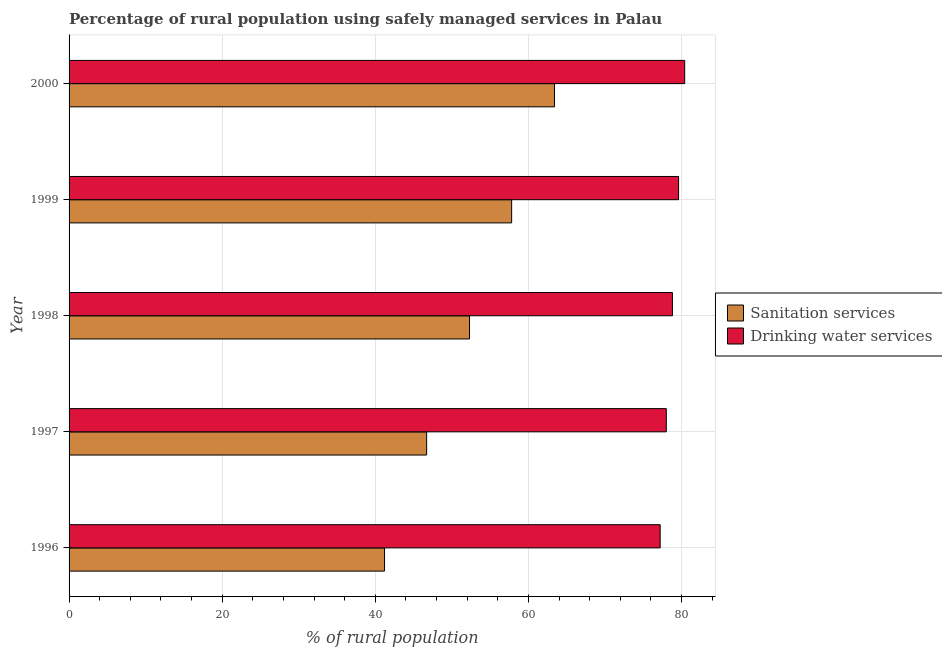How many different coloured bars are there?
Provide a succinct answer. 2. How many groups of bars are there?
Offer a very short reply. 5. Are the number of bars per tick equal to the number of legend labels?
Offer a terse response. Yes. Are the number of bars on each tick of the Y-axis equal?
Your response must be concise. Yes. How many bars are there on the 5th tick from the top?
Ensure brevity in your answer.  2. What is the label of the 4th group of bars from the top?
Give a very brief answer. 1997. In how many cases, is the number of bars for a given year not equal to the number of legend labels?
Give a very brief answer. 0. What is the percentage of rural population who used sanitation services in 2000?
Provide a succinct answer. 63.4. Across all years, what is the maximum percentage of rural population who used drinking water services?
Make the answer very short. 80.4. Across all years, what is the minimum percentage of rural population who used sanitation services?
Your answer should be very brief. 41.2. In which year was the percentage of rural population who used drinking water services maximum?
Make the answer very short. 2000. In which year was the percentage of rural population who used sanitation services minimum?
Provide a short and direct response. 1996. What is the total percentage of rural population who used sanitation services in the graph?
Your response must be concise. 261.4. What is the difference between the percentage of rural population who used drinking water services in 1998 and the percentage of rural population who used sanitation services in 1996?
Your answer should be compact. 37.6. What is the average percentage of rural population who used drinking water services per year?
Provide a succinct answer. 78.8. In the year 1997, what is the difference between the percentage of rural population who used sanitation services and percentage of rural population who used drinking water services?
Your answer should be very brief. -31.3. In how many years, is the percentage of rural population who used drinking water services greater than 12 %?
Provide a short and direct response. 5. What is the ratio of the percentage of rural population who used drinking water services in 1999 to that in 2000?
Offer a very short reply. 0.99. Is the percentage of rural population who used sanitation services in 1998 less than that in 2000?
Your answer should be very brief. Yes. Is the difference between the percentage of rural population who used sanitation services in 1998 and 2000 greater than the difference between the percentage of rural population who used drinking water services in 1998 and 2000?
Your response must be concise. No. What is the difference between the highest and the second highest percentage of rural population who used drinking water services?
Keep it short and to the point. 0.8. Is the sum of the percentage of rural population who used drinking water services in 1998 and 2000 greater than the maximum percentage of rural population who used sanitation services across all years?
Offer a terse response. Yes. What does the 1st bar from the top in 1996 represents?
Offer a very short reply. Drinking water services. What does the 2nd bar from the bottom in 1996 represents?
Give a very brief answer. Drinking water services. How many bars are there?
Give a very brief answer. 10. How many years are there in the graph?
Provide a short and direct response. 5. Are the values on the major ticks of X-axis written in scientific E-notation?
Offer a very short reply. No. Does the graph contain any zero values?
Your response must be concise. No. Where does the legend appear in the graph?
Keep it short and to the point. Center right. How are the legend labels stacked?
Your answer should be very brief. Vertical. What is the title of the graph?
Give a very brief answer. Percentage of rural population using safely managed services in Palau. What is the label or title of the X-axis?
Provide a succinct answer. % of rural population. What is the % of rural population in Sanitation services in 1996?
Give a very brief answer. 41.2. What is the % of rural population of Drinking water services in 1996?
Make the answer very short. 77.2. What is the % of rural population in Sanitation services in 1997?
Your answer should be compact. 46.7. What is the % of rural population of Drinking water services in 1997?
Offer a very short reply. 78. What is the % of rural population of Sanitation services in 1998?
Make the answer very short. 52.3. What is the % of rural population of Drinking water services in 1998?
Provide a succinct answer. 78.8. What is the % of rural population of Sanitation services in 1999?
Ensure brevity in your answer.  57.8. What is the % of rural population of Drinking water services in 1999?
Provide a short and direct response. 79.6. What is the % of rural population of Sanitation services in 2000?
Ensure brevity in your answer.  63.4. What is the % of rural population in Drinking water services in 2000?
Your answer should be very brief. 80.4. Across all years, what is the maximum % of rural population in Sanitation services?
Provide a short and direct response. 63.4. Across all years, what is the maximum % of rural population of Drinking water services?
Your answer should be very brief. 80.4. Across all years, what is the minimum % of rural population of Sanitation services?
Provide a short and direct response. 41.2. Across all years, what is the minimum % of rural population of Drinking water services?
Provide a short and direct response. 77.2. What is the total % of rural population in Sanitation services in the graph?
Offer a very short reply. 261.4. What is the total % of rural population of Drinking water services in the graph?
Keep it short and to the point. 394. What is the difference between the % of rural population in Sanitation services in 1996 and that in 1997?
Offer a very short reply. -5.5. What is the difference between the % of rural population of Sanitation services in 1996 and that in 1998?
Your answer should be very brief. -11.1. What is the difference between the % of rural population of Sanitation services in 1996 and that in 1999?
Your answer should be very brief. -16.6. What is the difference between the % of rural population of Drinking water services in 1996 and that in 1999?
Ensure brevity in your answer.  -2.4. What is the difference between the % of rural population in Sanitation services in 1996 and that in 2000?
Your answer should be compact. -22.2. What is the difference between the % of rural population in Drinking water services in 1997 and that in 1999?
Provide a succinct answer. -1.6. What is the difference between the % of rural population in Sanitation services in 1997 and that in 2000?
Ensure brevity in your answer.  -16.7. What is the difference between the % of rural population of Drinking water services in 1997 and that in 2000?
Offer a very short reply. -2.4. What is the difference between the % of rural population in Sanitation services in 1998 and that in 1999?
Keep it short and to the point. -5.5. What is the difference between the % of rural population of Drinking water services in 1998 and that in 2000?
Your response must be concise. -1.6. What is the difference between the % of rural population in Drinking water services in 1999 and that in 2000?
Make the answer very short. -0.8. What is the difference between the % of rural population of Sanitation services in 1996 and the % of rural population of Drinking water services in 1997?
Your response must be concise. -36.8. What is the difference between the % of rural population of Sanitation services in 1996 and the % of rural population of Drinking water services in 1998?
Keep it short and to the point. -37.6. What is the difference between the % of rural population in Sanitation services in 1996 and the % of rural population in Drinking water services in 1999?
Ensure brevity in your answer.  -38.4. What is the difference between the % of rural population in Sanitation services in 1996 and the % of rural population in Drinking water services in 2000?
Keep it short and to the point. -39.2. What is the difference between the % of rural population of Sanitation services in 1997 and the % of rural population of Drinking water services in 1998?
Offer a terse response. -32.1. What is the difference between the % of rural population in Sanitation services in 1997 and the % of rural population in Drinking water services in 1999?
Offer a very short reply. -32.9. What is the difference between the % of rural population in Sanitation services in 1997 and the % of rural population in Drinking water services in 2000?
Your answer should be compact. -33.7. What is the difference between the % of rural population in Sanitation services in 1998 and the % of rural population in Drinking water services in 1999?
Your response must be concise. -27.3. What is the difference between the % of rural population of Sanitation services in 1998 and the % of rural population of Drinking water services in 2000?
Make the answer very short. -28.1. What is the difference between the % of rural population of Sanitation services in 1999 and the % of rural population of Drinking water services in 2000?
Offer a very short reply. -22.6. What is the average % of rural population of Sanitation services per year?
Ensure brevity in your answer.  52.28. What is the average % of rural population of Drinking water services per year?
Offer a very short reply. 78.8. In the year 1996, what is the difference between the % of rural population of Sanitation services and % of rural population of Drinking water services?
Offer a terse response. -36. In the year 1997, what is the difference between the % of rural population of Sanitation services and % of rural population of Drinking water services?
Ensure brevity in your answer.  -31.3. In the year 1998, what is the difference between the % of rural population of Sanitation services and % of rural population of Drinking water services?
Provide a succinct answer. -26.5. In the year 1999, what is the difference between the % of rural population of Sanitation services and % of rural population of Drinking water services?
Offer a very short reply. -21.8. In the year 2000, what is the difference between the % of rural population in Sanitation services and % of rural population in Drinking water services?
Provide a short and direct response. -17. What is the ratio of the % of rural population of Sanitation services in 1996 to that in 1997?
Make the answer very short. 0.88. What is the ratio of the % of rural population of Sanitation services in 1996 to that in 1998?
Your answer should be compact. 0.79. What is the ratio of the % of rural population of Drinking water services in 1996 to that in 1998?
Your response must be concise. 0.98. What is the ratio of the % of rural population in Sanitation services in 1996 to that in 1999?
Your response must be concise. 0.71. What is the ratio of the % of rural population of Drinking water services in 1996 to that in 1999?
Ensure brevity in your answer.  0.97. What is the ratio of the % of rural population in Sanitation services in 1996 to that in 2000?
Give a very brief answer. 0.65. What is the ratio of the % of rural population in Drinking water services in 1996 to that in 2000?
Your response must be concise. 0.96. What is the ratio of the % of rural population in Sanitation services in 1997 to that in 1998?
Offer a terse response. 0.89. What is the ratio of the % of rural population in Sanitation services in 1997 to that in 1999?
Provide a succinct answer. 0.81. What is the ratio of the % of rural population in Drinking water services in 1997 to that in 1999?
Your response must be concise. 0.98. What is the ratio of the % of rural population of Sanitation services in 1997 to that in 2000?
Provide a succinct answer. 0.74. What is the ratio of the % of rural population of Drinking water services in 1997 to that in 2000?
Offer a very short reply. 0.97. What is the ratio of the % of rural population of Sanitation services in 1998 to that in 1999?
Your answer should be compact. 0.9. What is the ratio of the % of rural population in Sanitation services in 1998 to that in 2000?
Provide a short and direct response. 0.82. What is the ratio of the % of rural population of Drinking water services in 1998 to that in 2000?
Make the answer very short. 0.98. What is the ratio of the % of rural population of Sanitation services in 1999 to that in 2000?
Give a very brief answer. 0.91. What is the difference between the highest and the second highest % of rural population in Sanitation services?
Your response must be concise. 5.6. What is the difference between the highest and the lowest % of rural population of Drinking water services?
Your answer should be compact. 3.2. 